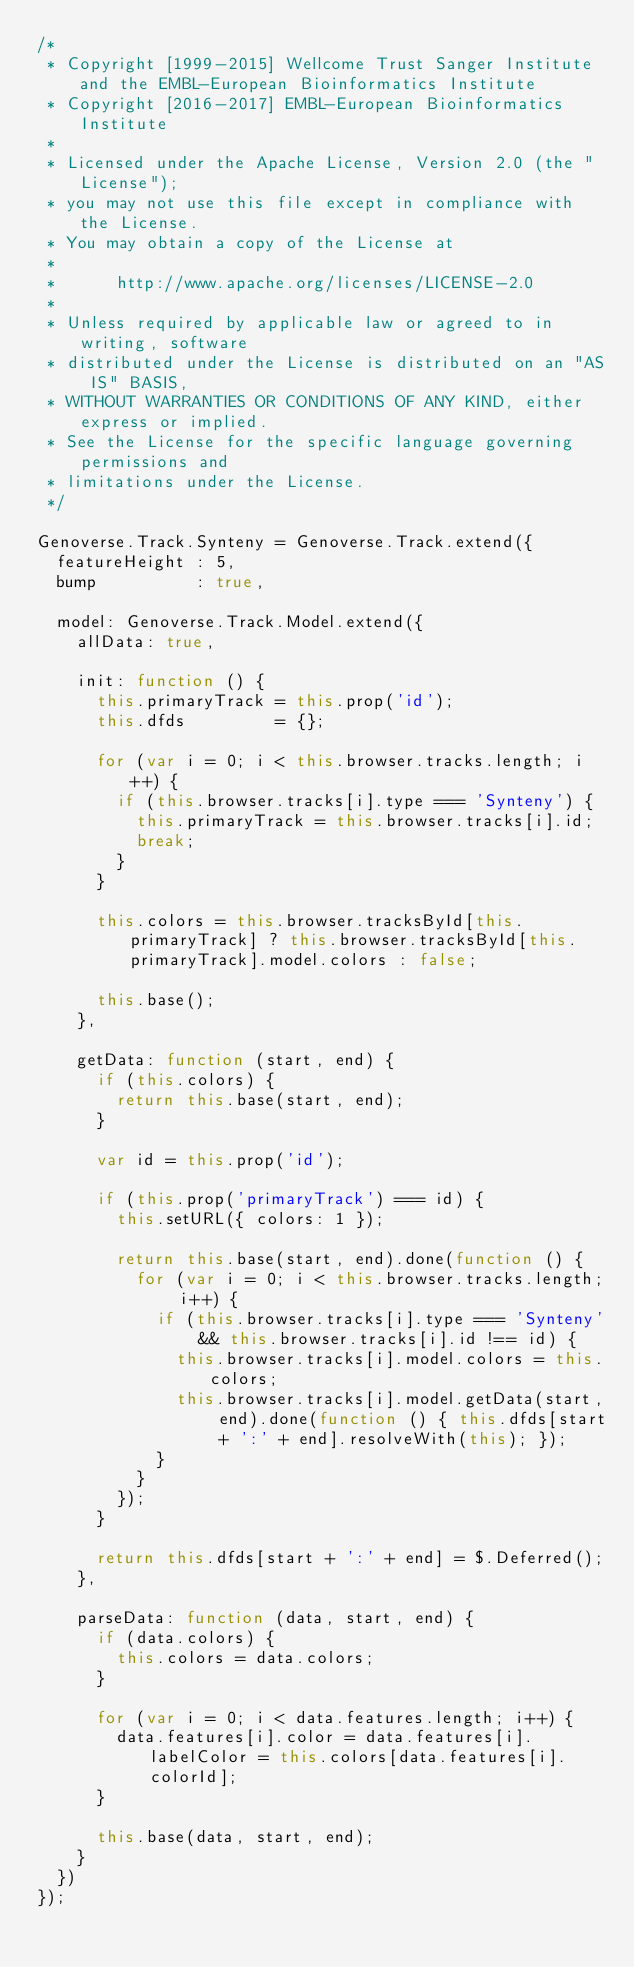<code> <loc_0><loc_0><loc_500><loc_500><_JavaScript_>/*
 * Copyright [1999-2015] Wellcome Trust Sanger Institute and the EMBL-European Bioinformatics Institute
 * Copyright [2016-2017] EMBL-European Bioinformatics Institute
 * 
 * Licensed under the Apache License, Version 2.0 (the "License");
 * you may not use this file except in compliance with the License.
 * You may obtain a copy of the License at
 * 
 *      http://www.apache.org/licenses/LICENSE-2.0
 * 
 * Unless required by applicable law or agreed to in writing, software
 * distributed under the License is distributed on an "AS IS" BASIS,
 * WITHOUT WARRANTIES OR CONDITIONS OF ANY KIND, either express or implied.
 * See the License for the specific language governing permissions and
 * limitations under the License.
 */

Genoverse.Track.Synteny = Genoverse.Track.extend({
  featureHeight : 5,
  bump          : true,
  
  model: Genoverse.Track.Model.extend({
    allData: true,
    
    init: function () {
      this.primaryTrack = this.prop('id');
      this.dfds         = {};
      
      for (var i = 0; i < this.browser.tracks.length; i++) {
        if (this.browser.tracks[i].type === 'Synteny') {
          this.primaryTrack = this.browser.tracks[i].id;
          break;
        }
      }
      
      this.colors = this.browser.tracksById[this.primaryTrack] ? this.browser.tracksById[this.primaryTrack].model.colors : false;
      
      this.base();
    },
    
    getData: function (start, end) {
      if (this.colors) {
        return this.base(start, end);
      }
      
      var id = this.prop('id');
      
      if (this.prop('primaryTrack') === id) {
        this.setURL({ colors: 1 });
        
        return this.base(start, end).done(function () {
          for (var i = 0; i < this.browser.tracks.length; i++) {
            if (this.browser.tracks[i].type === 'Synteny' && this.browser.tracks[i].id !== id) {
              this.browser.tracks[i].model.colors = this.colors;
              this.browser.tracks[i].model.getData(start, end).done(function () { this.dfds[start + ':' + end].resolveWith(this); });
            }
          }
        });
      }
      
      return this.dfds[start + ':' + end] = $.Deferred();
    },
    
    parseData: function (data, start, end) {
      if (data.colors) {
        this.colors = data.colors;
      }
      
      for (var i = 0; i < data.features.length; i++) {
        data.features[i].color = data.features[i].labelColor = this.colors[data.features[i].colorId];
      }
      
      this.base(data, start, end);
    }
  })
});</code> 